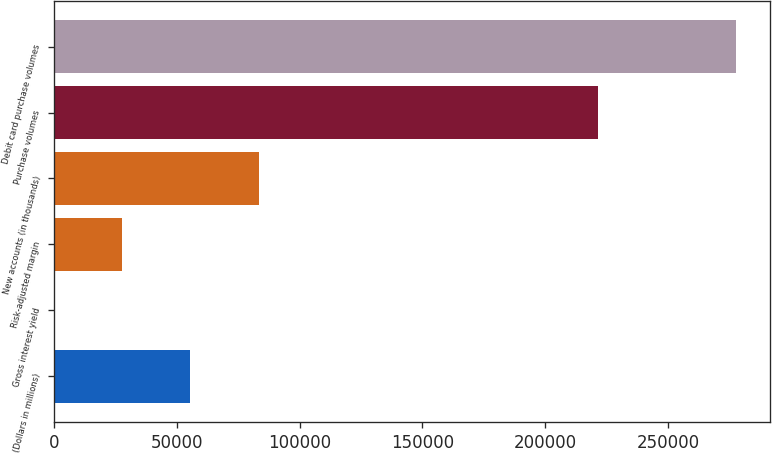Convert chart. <chart><loc_0><loc_0><loc_500><loc_500><bar_chart><fcel>(Dollars in millions)<fcel>Gross interest yield<fcel>Risk-adjusted margin<fcel>New accounts (in thousands)<fcel>Purchase volumes<fcel>Debit card purchase volumes<nl><fcel>55546.3<fcel>9.16<fcel>27777.7<fcel>83314.9<fcel>221378<fcel>277695<nl></chart> 